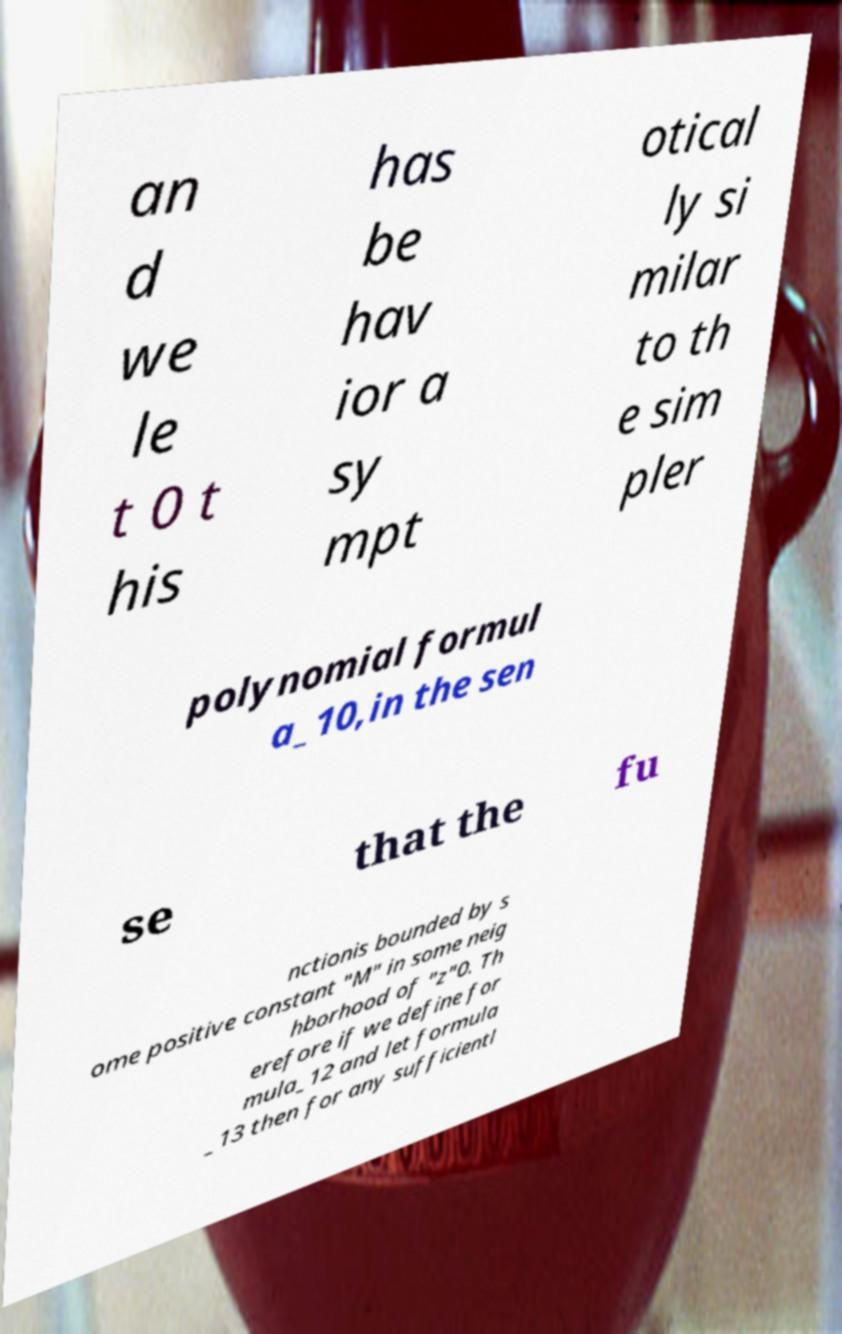For documentation purposes, I need the text within this image transcribed. Could you provide that? an d we le t 0 t his has be hav ior a sy mpt otical ly si milar to th e sim pler polynomial formul a_10,in the sen se that the fu nctionis bounded by s ome positive constant "M" in some neig hborhood of "z"0. Th erefore if we define for mula_12 and let formula _13 then for any sufficientl 